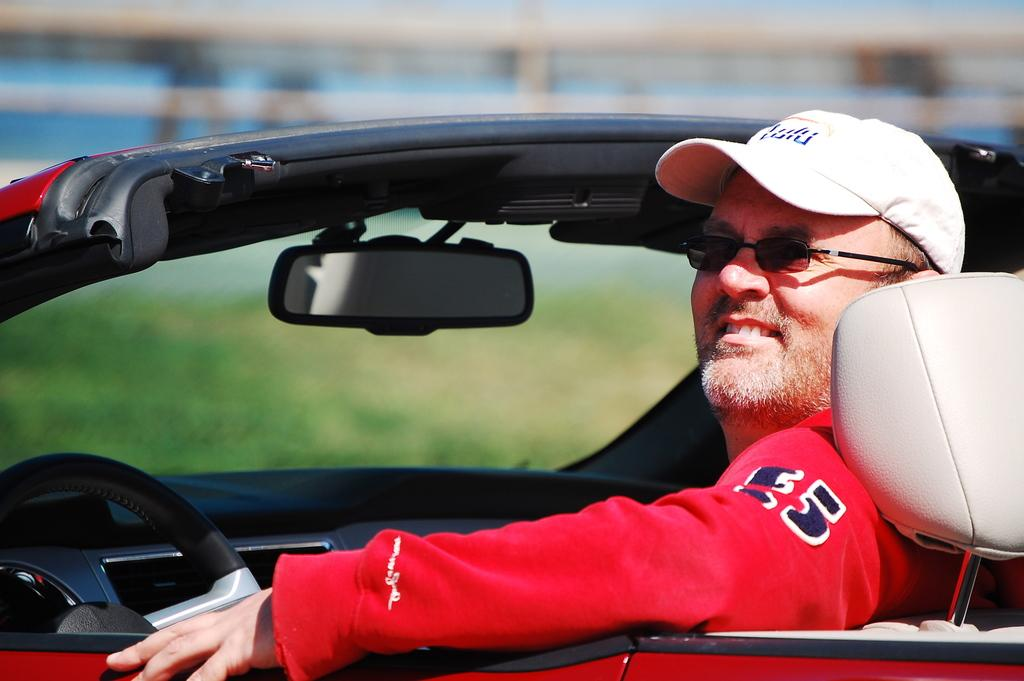What is the man inside in the image? There is a man inside a vehicle in the image. What accessories is the man wearing? The man is wearing spectacles and a cap. Can you identify any other objects in the image? Yes, there is a mirror in the image. What type of plate is being used to serve the sleet in the image? There is no plate or sleet present in the image. What kind of feast is being celebrated in the image? There is no feast or celebration depicted in the image. 